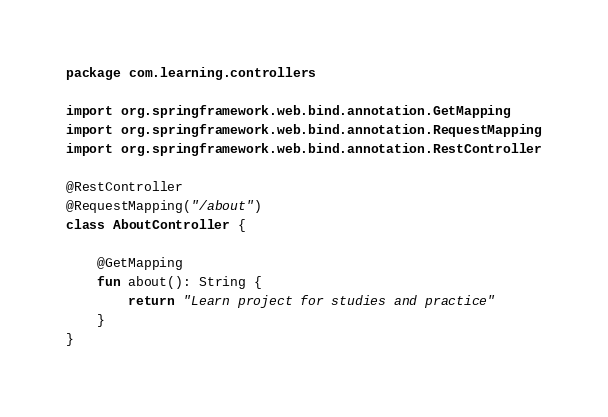<code> <loc_0><loc_0><loc_500><loc_500><_Kotlin_>package com.learning.controllers

import org.springframework.web.bind.annotation.GetMapping
import org.springframework.web.bind.annotation.RequestMapping
import org.springframework.web.bind.annotation.RestController

@RestController
@RequestMapping("/about")
class AboutController {

    @GetMapping
    fun about(): String {
        return "Learn project for studies and practice"
    }
}</code> 